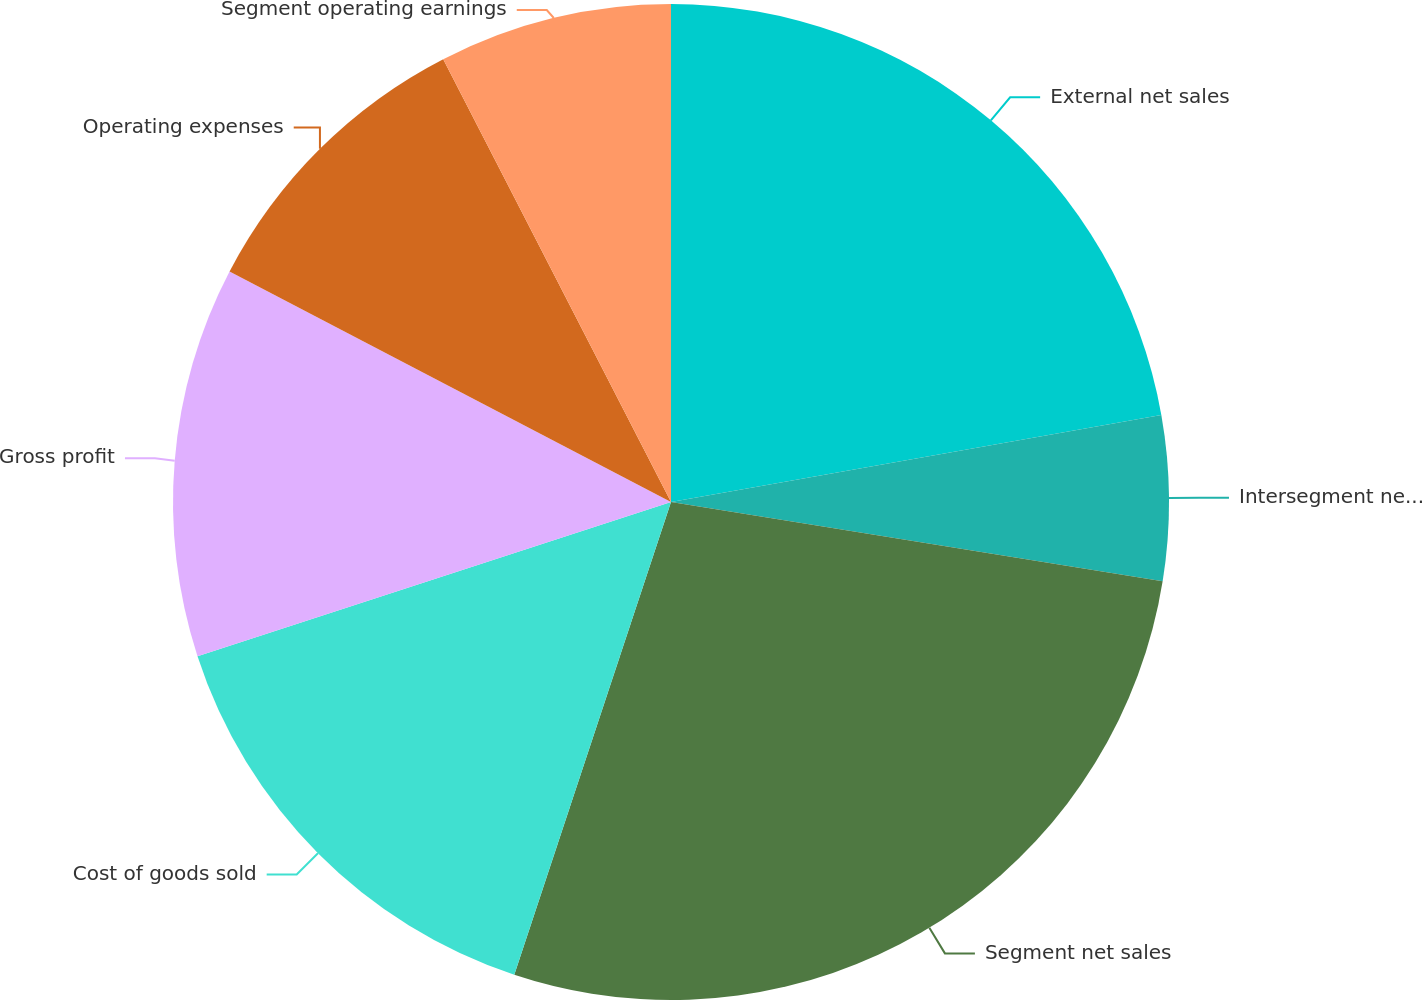<chart> <loc_0><loc_0><loc_500><loc_500><pie_chart><fcel>External net sales<fcel>Intersegment net sales<fcel>Segment net sales<fcel>Cost of goods sold<fcel>Gross profit<fcel>Operating expenses<fcel>Segment operating earnings<nl><fcel>22.2%<fcel>5.34%<fcel>27.55%<fcel>14.89%<fcel>12.67%<fcel>9.78%<fcel>7.56%<nl></chart> 